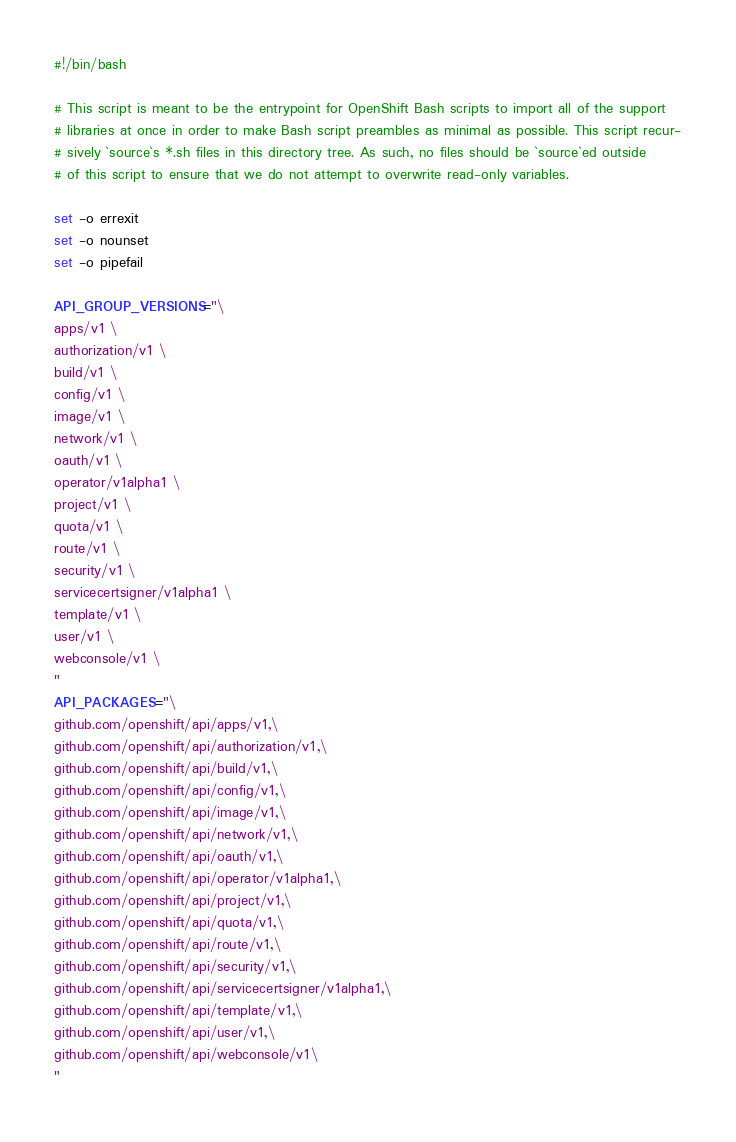<code> <loc_0><loc_0><loc_500><loc_500><_Bash_>#!/bin/bash

# This script is meant to be the entrypoint for OpenShift Bash scripts to import all of the support
# libraries at once in order to make Bash script preambles as minimal as possible. This script recur-
# sively `source`s *.sh files in this directory tree. As such, no files should be `source`ed outside
# of this script to ensure that we do not attempt to overwrite read-only variables.

set -o errexit
set -o nounset
set -o pipefail

API_GROUP_VERSIONS="\
apps/v1 \
authorization/v1 \
build/v1 \
config/v1 \
image/v1 \
network/v1 \
oauth/v1 \
operator/v1alpha1 \
project/v1 \
quota/v1 \
route/v1 \
security/v1 \
servicecertsigner/v1alpha1 \
template/v1 \
user/v1 \
webconsole/v1 \
"
API_PACKAGES="\
github.com/openshift/api/apps/v1,\
github.com/openshift/api/authorization/v1,\
github.com/openshift/api/build/v1,\
github.com/openshift/api/config/v1,\
github.com/openshift/api/image/v1,\
github.com/openshift/api/network/v1,\
github.com/openshift/api/oauth/v1,\
github.com/openshift/api/operator/v1alpha1,\
github.com/openshift/api/project/v1,\
github.com/openshift/api/quota/v1,\
github.com/openshift/api/route/v1,\
github.com/openshift/api/security/v1,\
github.com/openshift/api/servicecertsigner/v1alpha1,\
github.com/openshift/api/template/v1,\
github.com/openshift/api/user/v1,\
github.com/openshift/api/webconsole/v1\
"
</code> 